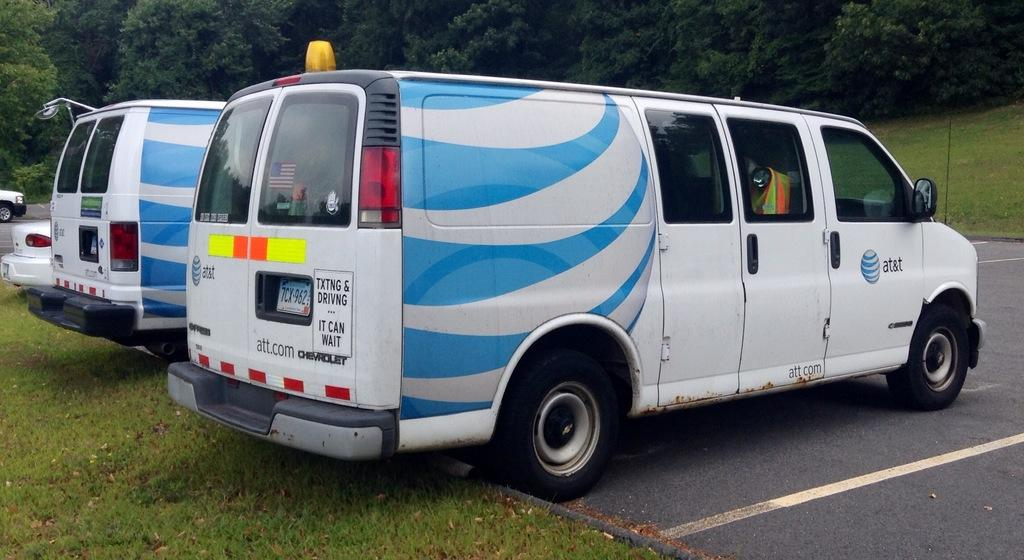What types of objects are present in the image? There are vehicles in the image. Can you describe one of the vehicles in the image? One of the vehicles is blue and white in color. What else can be seen in the image besides the vehicles? There are trees visible in the image. What is the color of the trees in the image? The trees are green in color. How many feet are visible on the duck in the image? There is no duck present in the image, so it is not possible to determine the number of feet visible on a duck. 